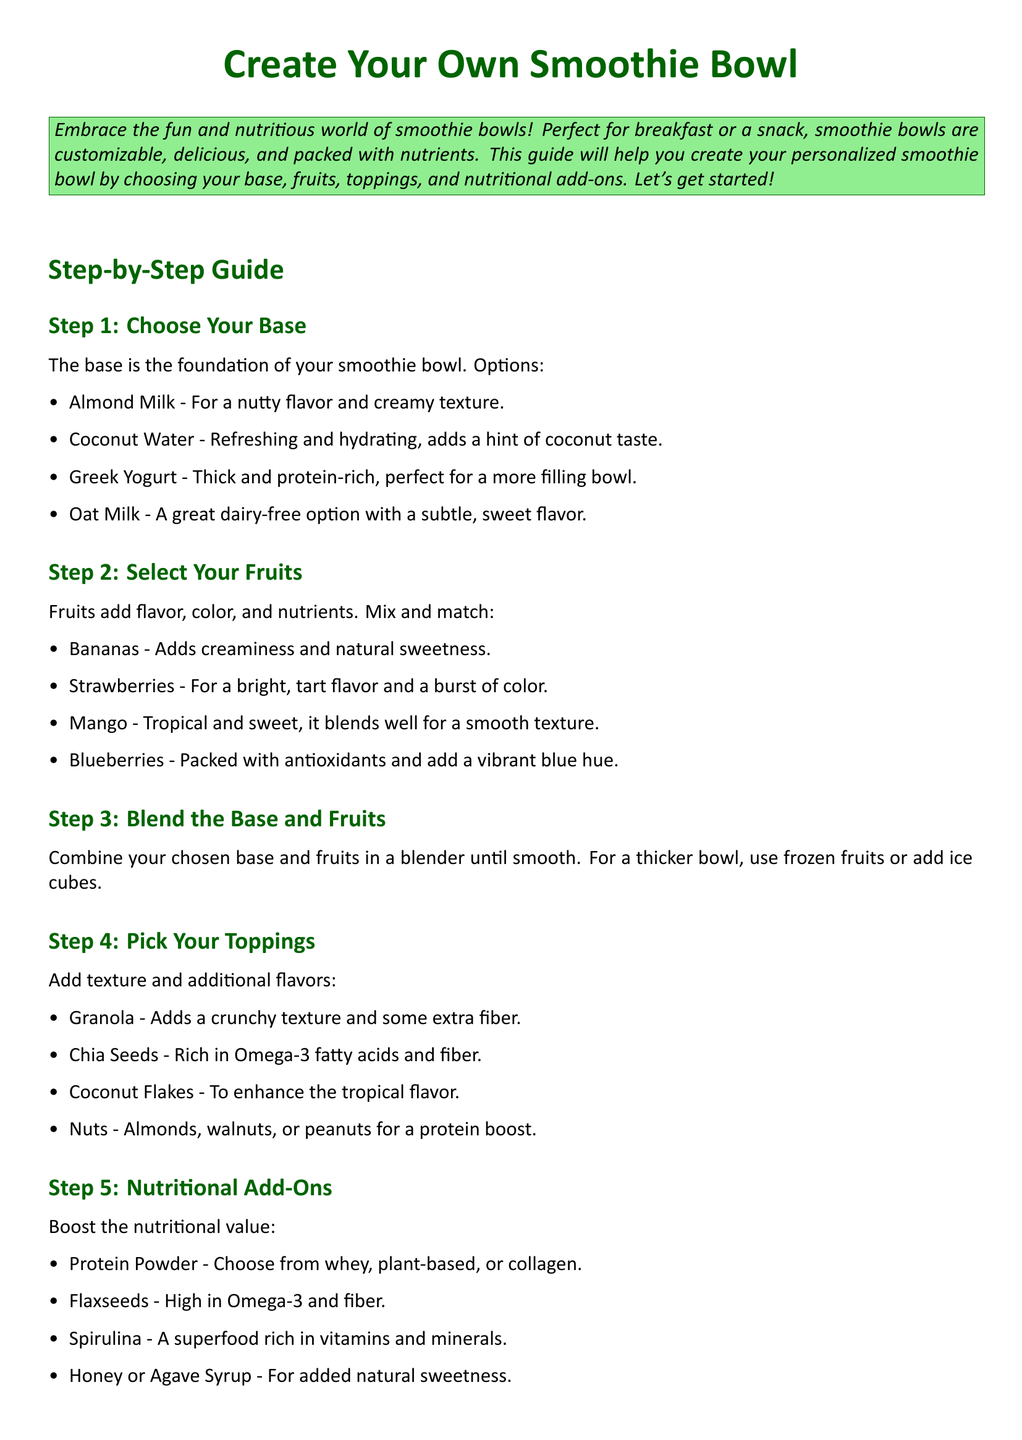What is the first step in creating a smoothie bowl? The first step listed in the document is to choose your base.
Answer: Choose Your Base What type of milk is suggested for a nutty flavor? The document mentions almond milk for a nutty flavor.
Answer: Almond Milk Which fruit is associated with a tropical flavor? Mango is identified in the document as having a tropical and sweet flavor.
Answer: Mango What is an ingredient that can enhance the nutritional value? The document lists protein powder as a nutritional add-on.
Answer: Protein Powder What type of texture do chia seeds add? Chia seeds are described as rich in Omega-3 fatty acids and fiber, contributing to texture.
Answer: Crunchy How many base options are provided? There are four base options mentioned for smoothie bowls.
Answer: Four What is the purpose of the toppings? Toppings are added to provide texture and additional flavors.
Answer: Texture and additional flavors What should you use if you want a thicker bowl? The document suggests using frozen fruits or adding ice cubes for a thicker bowl.
Answer: Frozen fruits or ice cubes Which natural sweetener is mentioned as an option? Honey or agave syrup is provided as a natural sweetener.
Answer: Honey or Agave Syrup What should you do after blending the base and fruits? The next step is to assemble and enjoy your smoothie bowl.
Answer: Assemble and Enjoy 